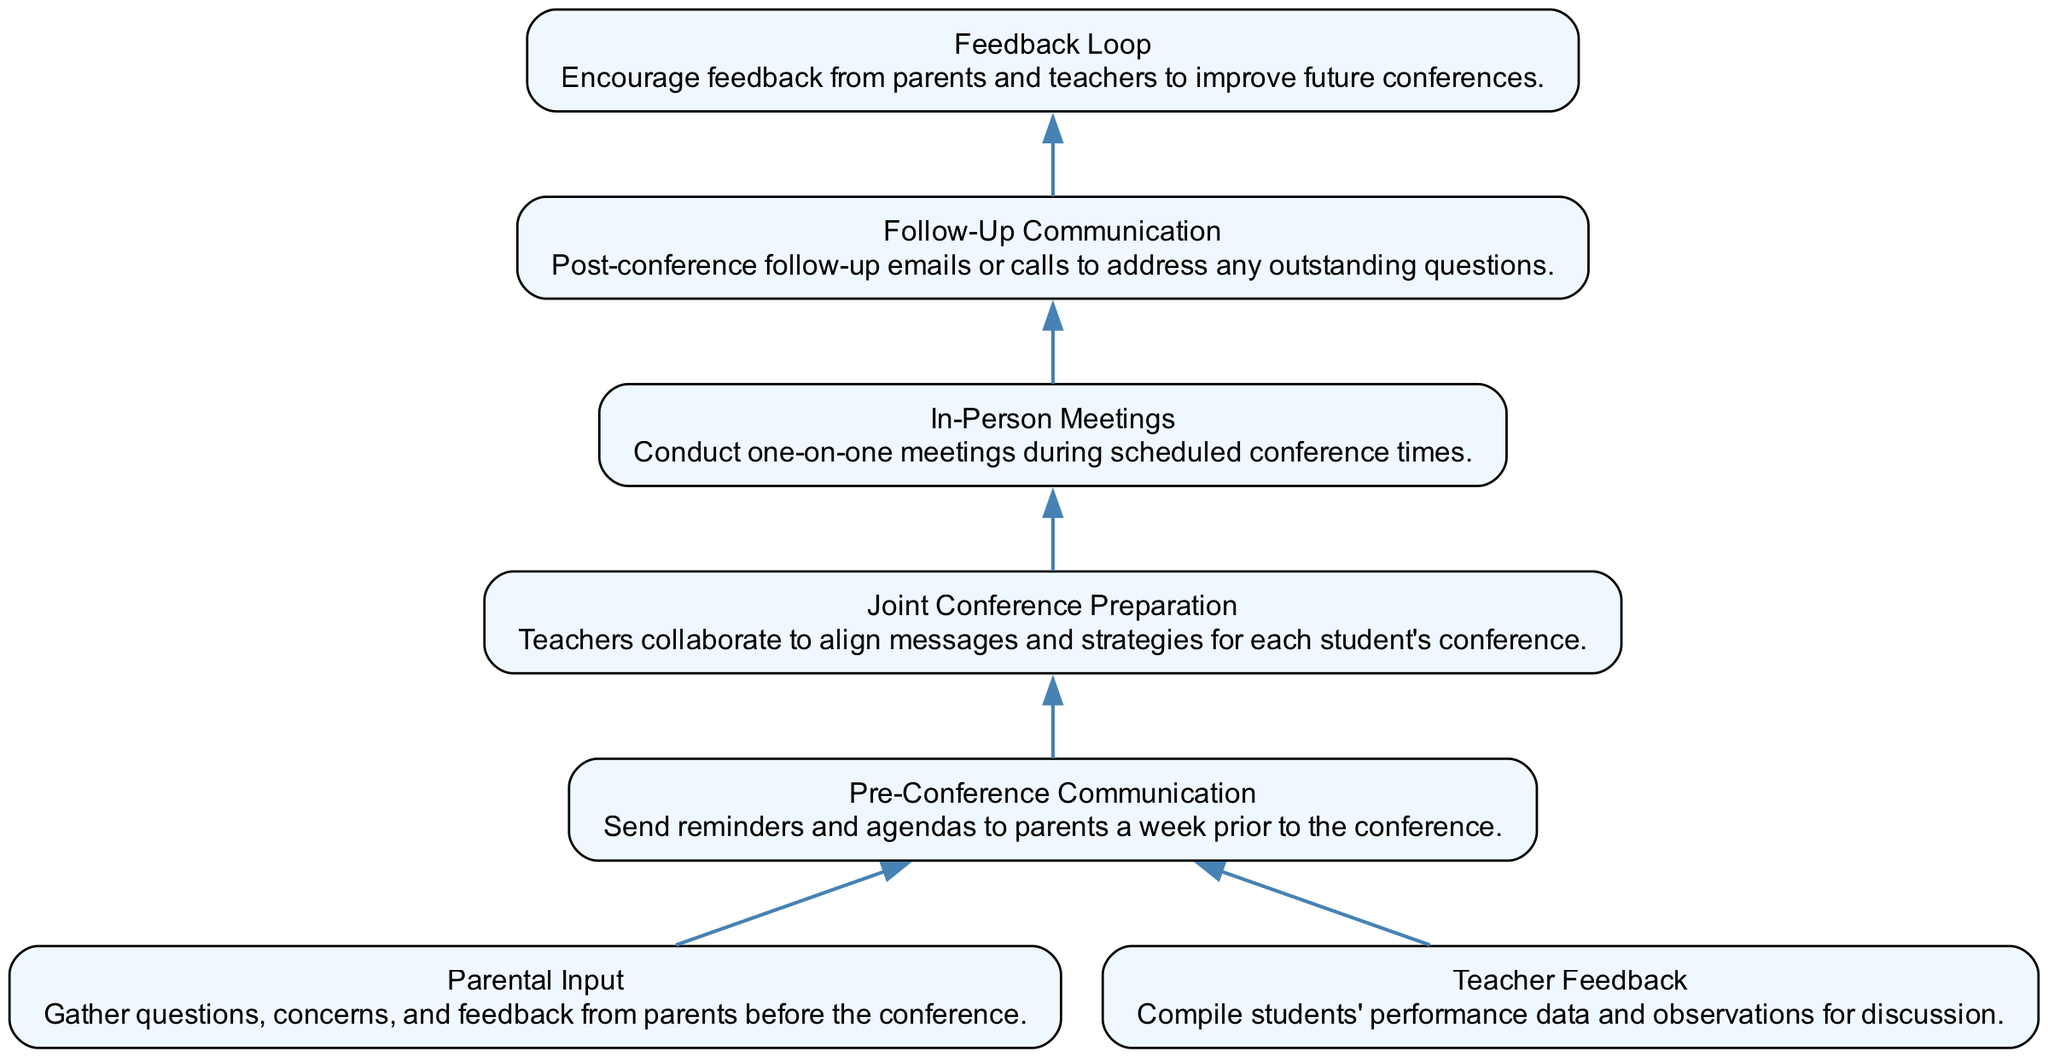What is the first step in the communication flow? The diagram shows that the first step in the communication flow is "Parental Input," where questions, concerns, and feedback are gathered from parents.
Answer: Parental Input How many nodes are there in the diagram? By counting each unique labeled box in the diagram, we can determine there are a total of 7 nodes.
Answer: 7 What is the last step in the flow? The final step as displayed in the diagram is "Feedback Loop," which encourages feedback from parents and teachers.
Answer: Feedback Loop Which step follows "In-Person Meetings"? The diagram indicates that "Follow-Up Communication" follows after "In-Person Meetings," showing that post-conference communication is necessary.
Answer: Follow-Up Communication Which two steps lead to "Pre-Conference Communication"? The flow chart shows that both "Parental Input" and "Teacher Feedback" lead to "Pre-Conference Communication," indicating that both parents and teachers contribute to preparing for the conference.
Answer: Parental Input and Teacher Feedback What do "Joint Conference Preparation" and "In-Person Meetings" have in common in the flow? Both "Joint Conference Preparation" and "In-Person Meetings" are sequential steps that focus on conference activities, indicating they are part of the same phase of the process.
Answer: They are part of conference activities What role does the "Feedback Loop" play at the end of the flow? The "Feedback Loop" is a step designed to encourage continuous improvement by gathering insights from both parents and teachers about the conference process, indicating its importance in future events.
Answer: Continuous improvement 